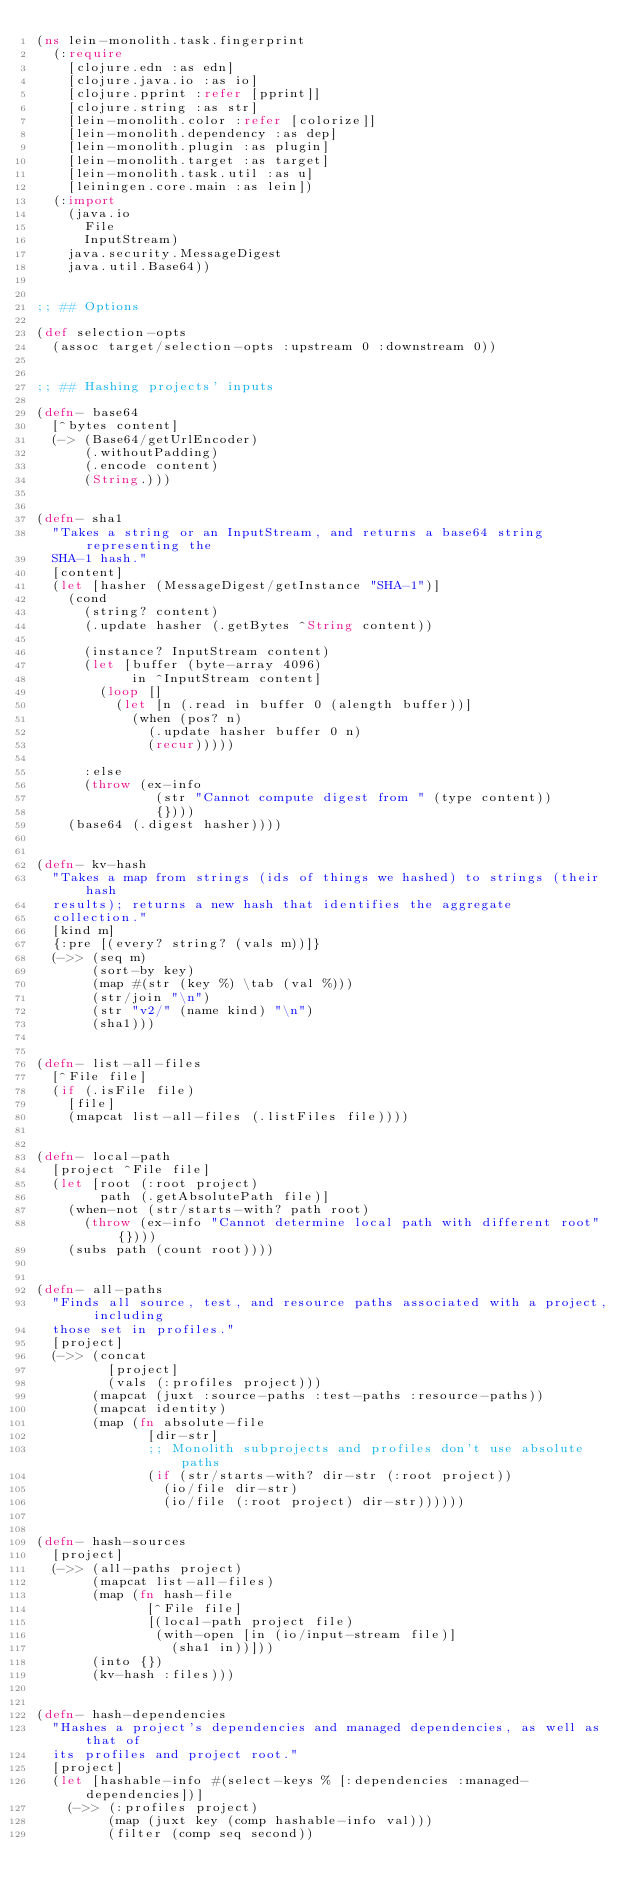<code> <loc_0><loc_0><loc_500><loc_500><_Clojure_>(ns lein-monolith.task.fingerprint
  (:require
    [clojure.edn :as edn]
    [clojure.java.io :as io]
    [clojure.pprint :refer [pprint]]
    [clojure.string :as str]
    [lein-monolith.color :refer [colorize]]
    [lein-monolith.dependency :as dep]
    [lein-monolith.plugin :as plugin]
    [lein-monolith.target :as target]
    [lein-monolith.task.util :as u]
    [leiningen.core.main :as lein])
  (:import
    (java.io
      File
      InputStream)
    java.security.MessageDigest
    java.util.Base64))


;; ## Options

(def selection-opts
  (assoc target/selection-opts :upstream 0 :downstream 0))


;; ## Hashing projects' inputs

(defn- base64
  [^bytes content]
  (-> (Base64/getUrlEncoder)
      (.withoutPadding)
      (.encode content)
      (String.)))


(defn- sha1
  "Takes a string or an InputStream, and returns a base64 string representing the
  SHA-1 hash."
  [content]
  (let [hasher (MessageDigest/getInstance "SHA-1")]
    (cond
      (string? content)
      (.update hasher (.getBytes ^String content))

      (instance? InputStream content)
      (let [buffer (byte-array 4096)
            in ^InputStream content]
        (loop []
          (let [n (.read in buffer 0 (alength buffer))]
            (when (pos? n)
              (.update hasher buffer 0 n)
              (recur)))))

      :else
      (throw (ex-info
               (str "Cannot compute digest from " (type content))
               {})))
    (base64 (.digest hasher))))


(defn- kv-hash
  "Takes a map from strings (ids of things we hashed) to strings (their hash
  results); returns a new hash that identifies the aggregate
  collection."
  [kind m]
  {:pre [(every? string? (vals m))]}
  (->> (seq m)
       (sort-by key)
       (map #(str (key %) \tab (val %)))
       (str/join "\n")
       (str "v2/" (name kind) "\n")
       (sha1)))


(defn- list-all-files
  [^File file]
  (if (.isFile file)
    [file]
    (mapcat list-all-files (.listFiles file))))


(defn- local-path
  [project ^File file]
  (let [root (:root project)
        path (.getAbsolutePath file)]
    (when-not (str/starts-with? path root)
      (throw (ex-info "Cannot determine local path with different root" {})))
    (subs path (count root))))


(defn- all-paths
  "Finds all source, test, and resource paths associated with a project, including
  those set in profiles."
  [project]
  (->> (concat
         [project]
         (vals (:profiles project)))
       (mapcat (juxt :source-paths :test-paths :resource-paths))
       (mapcat identity)
       (map (fn absolute-file
              [dir-str]
              ;; Monolith subprojects and profiles don't use absolute paths
              (if (str/starts-with? dir-str (:root project))
                (io/file dir-str)
                (io/file (:root project) dir-str))))))


(defn- hash-sources
  [project]
  (->> (all-paths project)
       (mapcat list-all-files)
       (map (fn hash-file
              [^File file]
              [(local-path project file)
               (with-open [in (io/input-stream file)]
                 (sha1 in))]))
       (into {})
       (kv-hash :files)))


(defn- hash-dependencies
  "Hashes a project's dependencies and managed dependencies, as well as that of
  its profiles and project root."
  [project]
  (let [hashable-info #(select-keys % [:dependencies :managed-dependencies])]
    (->> (:profiles project)
         (map (juxt key (comp hashable-info val)))
         (filter (comp seq second))</code> 